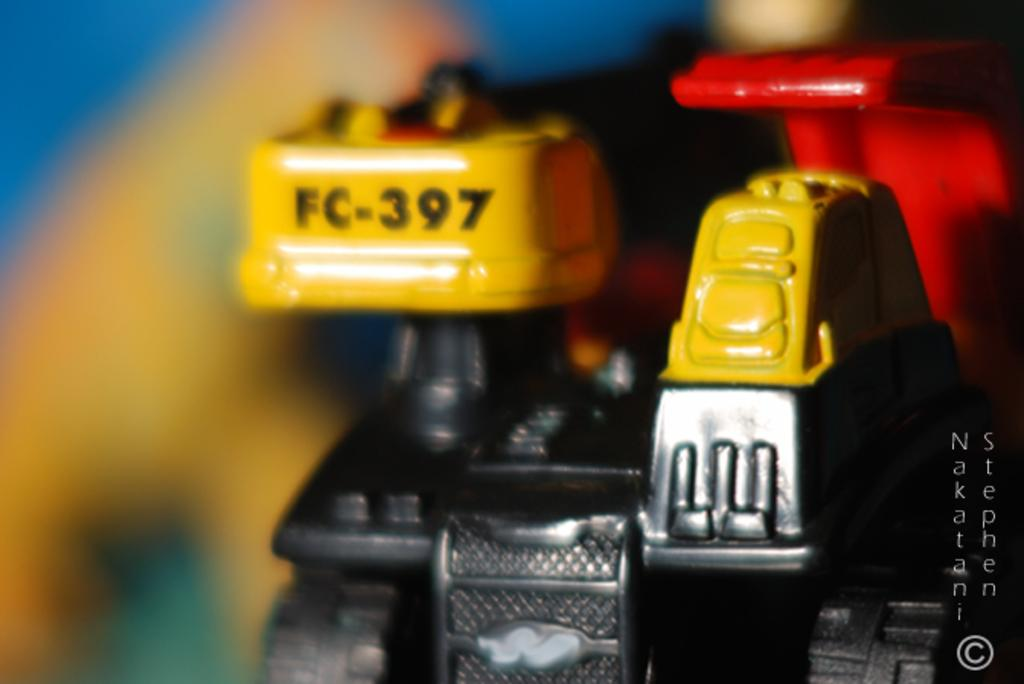<image>
Relay a brief, clear account of the picture shown. A yellow and red tool says FC-397 on it. 